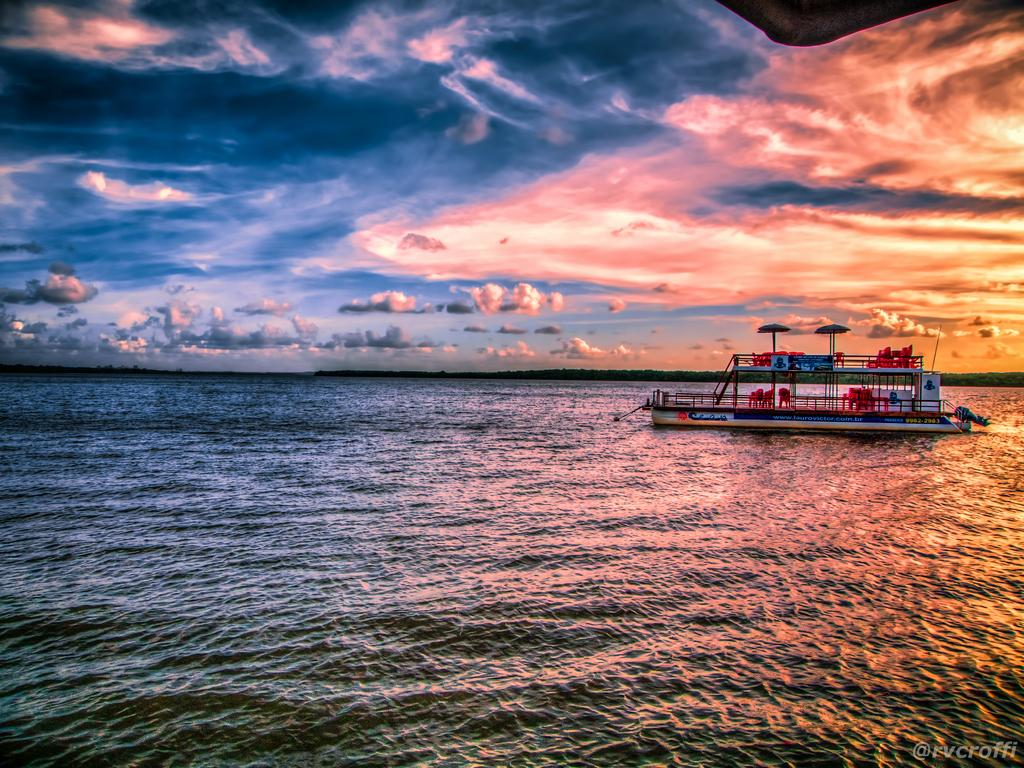What is the main subject of the image? The main subject of the image is a boat. Where is the boat located? The boat is on the water. What type of furniture is on the boat? There are chairs on the boat. What type of shade is provided on the boat? There are umbrellas on the boat. What can be seen in the background of the image? The sky is visible in the background of the image. What is the condition of the sky in the image? There are clouds in the sky. What type of silver material is used to make the swing on the boat? There is no swing present on the boat in the image. 